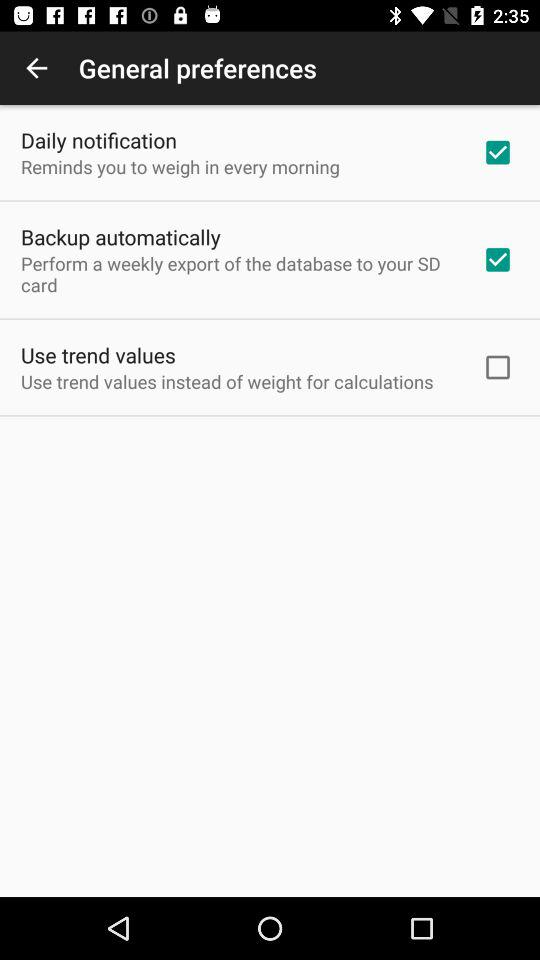What is the status of "Use trend values"? The status of "Use trend values" is "off". 